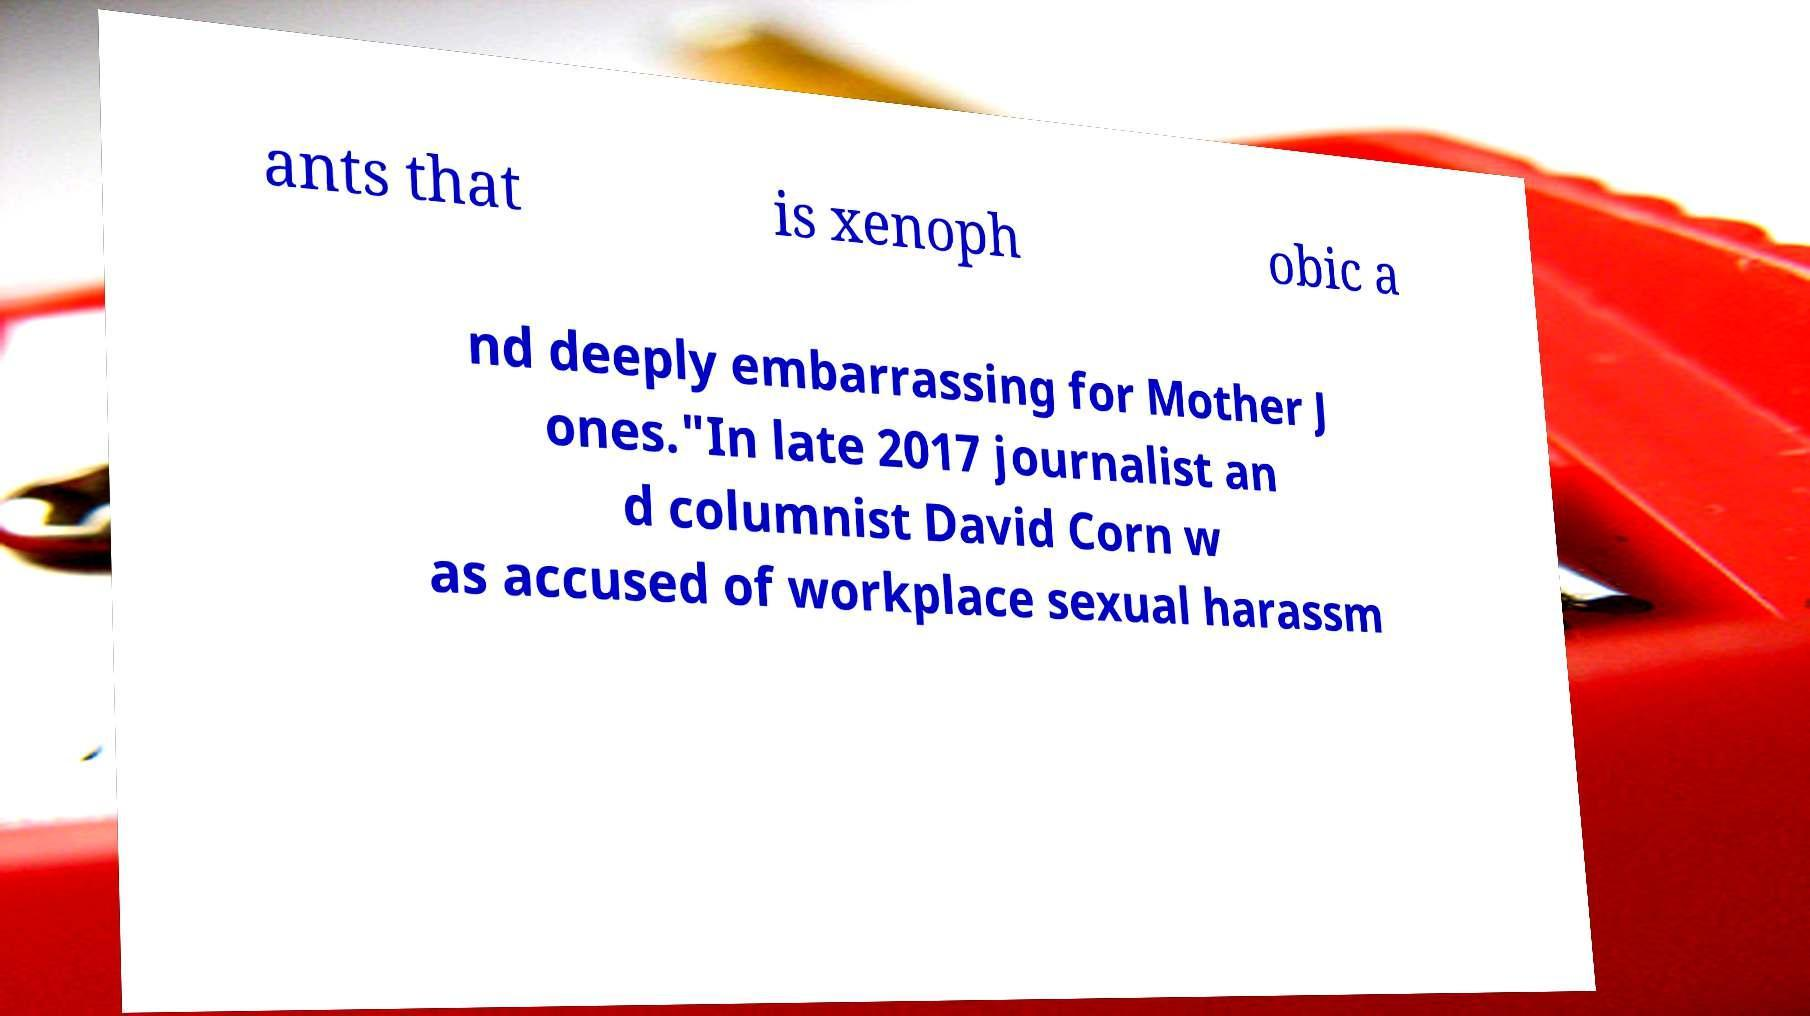What messages or text are displayed in this image? I need them in a readable, typed format. ants that is xenoph obic a nd deeply embarrassing for Mother J ones."In late 2017 journalist an d columnist David Corn w as accused of workplace sexual harassm 